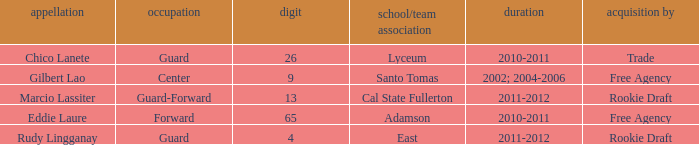What number has an acquisition via the Rookie Draft, and is part of a School/club team at Cal State Fullerton? 13.0. 